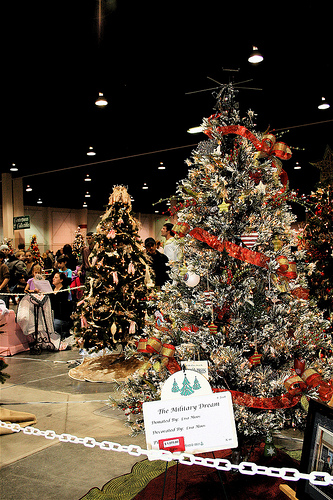<image>
Can you confirm if the tree is next to the tree? Yes. The tree is positioned adjacent to the tree, located nearby in the same general area. 